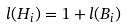<formula> <loc_0><loc_0><loc_500><loc_500>l ( H _ { i } ) = 1 + l ( B _ { i } )</formula> 